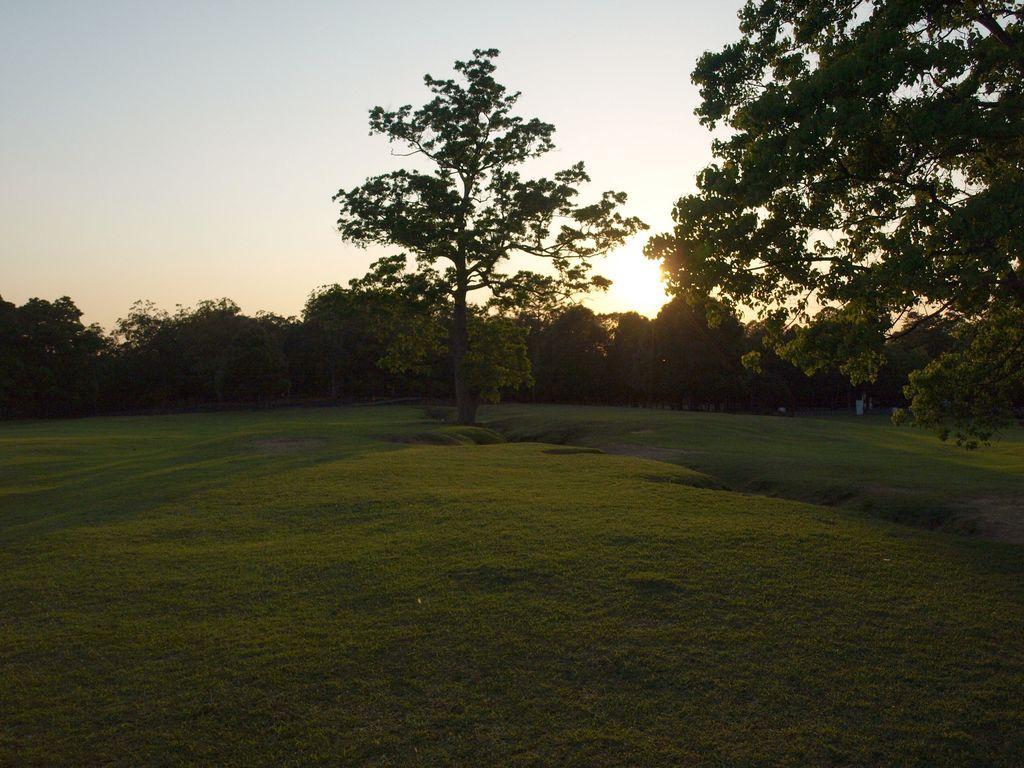Can you describe this image briefly? In this picture I can see there are grass, trees and the sky is clear with sunset. 